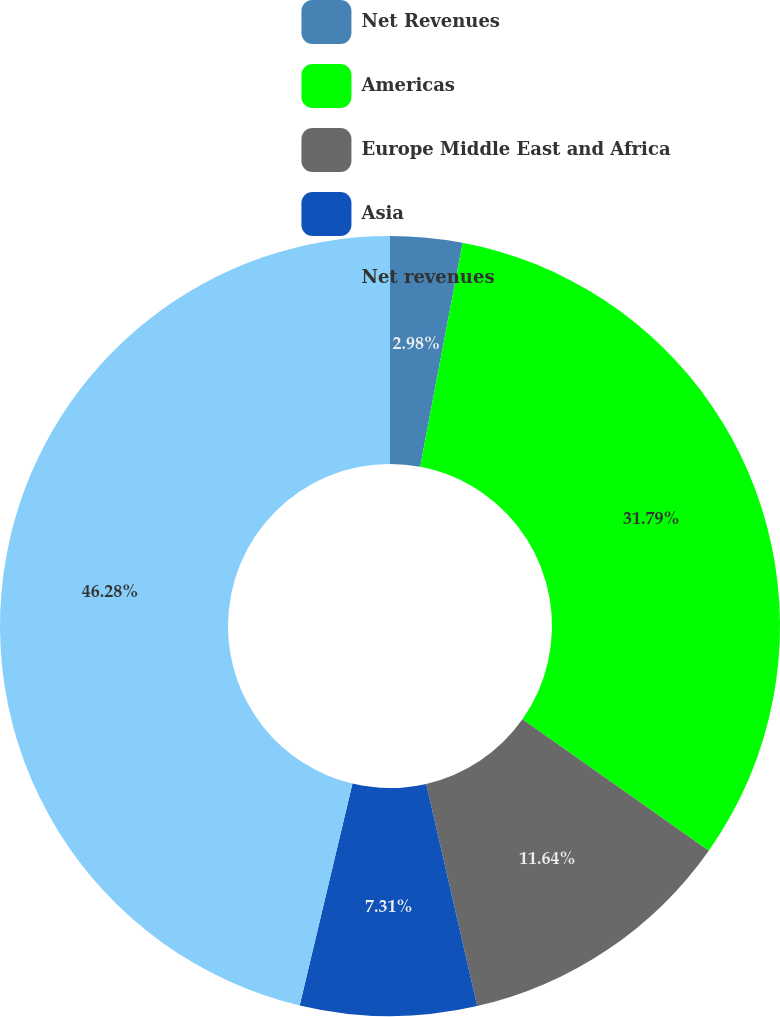Convert chart. <chart><loc_0><loc_0><loc_500><loc_500><pie_chart><fcel>Net Revenues<fcel>Americas<fcel>Europe Middle East and Africa<fcel>Asia<fcel>Net revenues<nl><fcel>2.98%<fcel>31.79%<fcel>11.64%<fcel>7.31%<fcel>46.28%<nl></chart> 